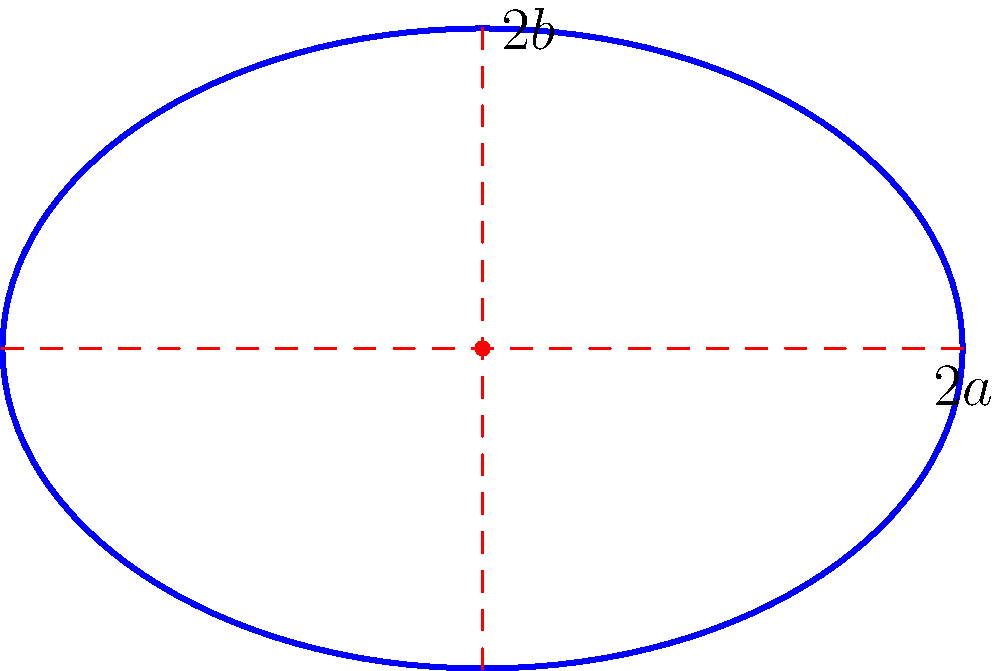During your floor routine, you perform a hoop manipulation where the hoop traces an elliptical path on the floor. If the major axis of this ellipse is 6 meters and the minor axis is 4 meters, what is the area of the ellipse formed by your hoop's motion? Let's approach this step-by-step:

1) The formula for the area of an ellipse is:

   $$A = \pi ab$$

   where $a$ is half the length of the major axis and $b$ is half the length of the minor axis.

2) We're given that the major axis is 6 meters, so $a = 3$ meters.
   The minor axis is 4 meters, so $b = 2$ meters.

3) Substituting these values into our formula:

   $$A = \pi (3)(2)$$

4) Simplify:
   $$A = 6\pi$$

5) If we want to calculate this numerically, we can use $\pi \approx 3.14159$:

   $$A \approx 6(3.14159) \approx 18.85 \text{ square meters}$$

Thus, the area of the ellipse formed by your hoop's motion is $6\pi$ or approximately 18.85 square meters.
Answer: $6\pi$ square meters 